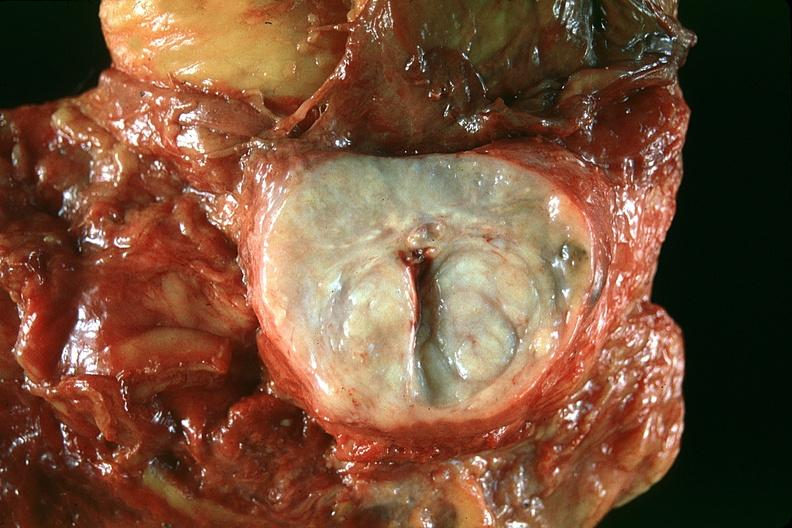what does this image show?
Answer the question using a single word or phrase. Normal prostate 